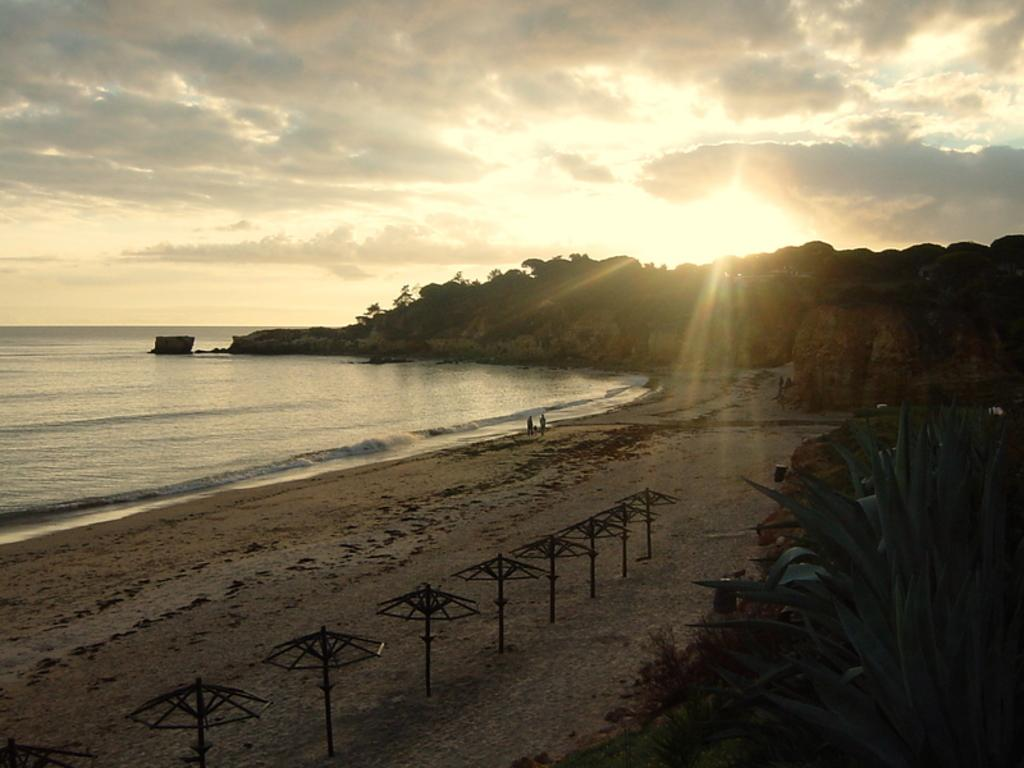What type of living organisms can be seen in the image? Plants and trees are visible in the image. What can be seen in the background of the image? People walking and water can be seen in the background of the image. What type of terrain is visible in the image? Hills are visible in the image. What is the opinion of the chairs in the image? There are no chairs present in the image, so it is not possible to determine their opinion. 